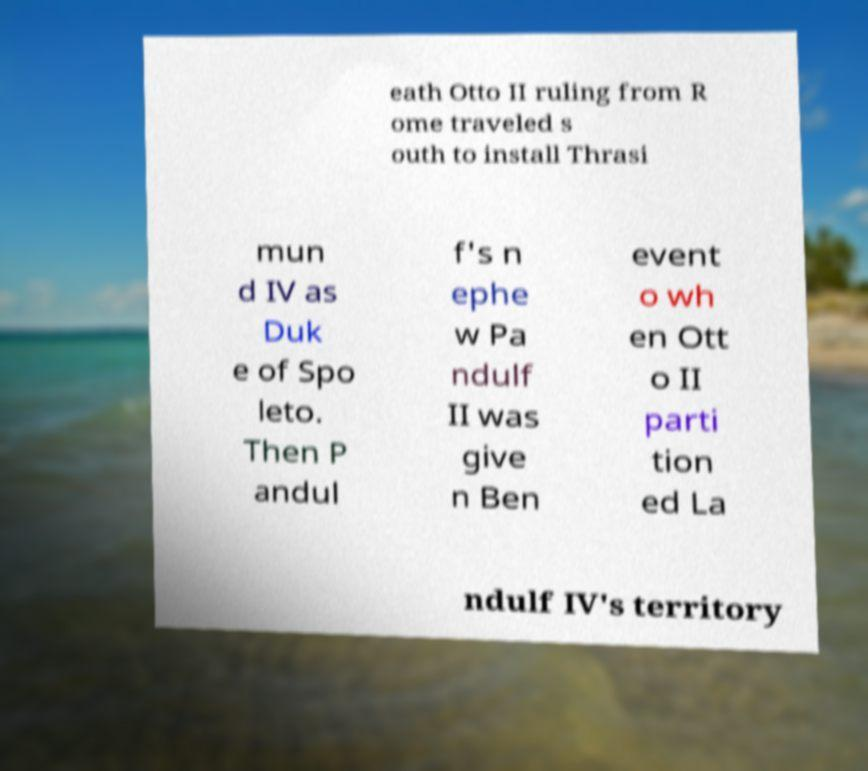Can you read and provide the text displayed in the image?This photo seems to have some interesting text. Can you extract and type it out for me? eath Otto II ruling from R ome traveled s outh to install Thrasi mun d IV as Duk e of Spo leto. Then P andul f's n ephe w Pa ndulf II was give n Ben event o wh en Ott o II parti tion ed La ndulf IV's territory 